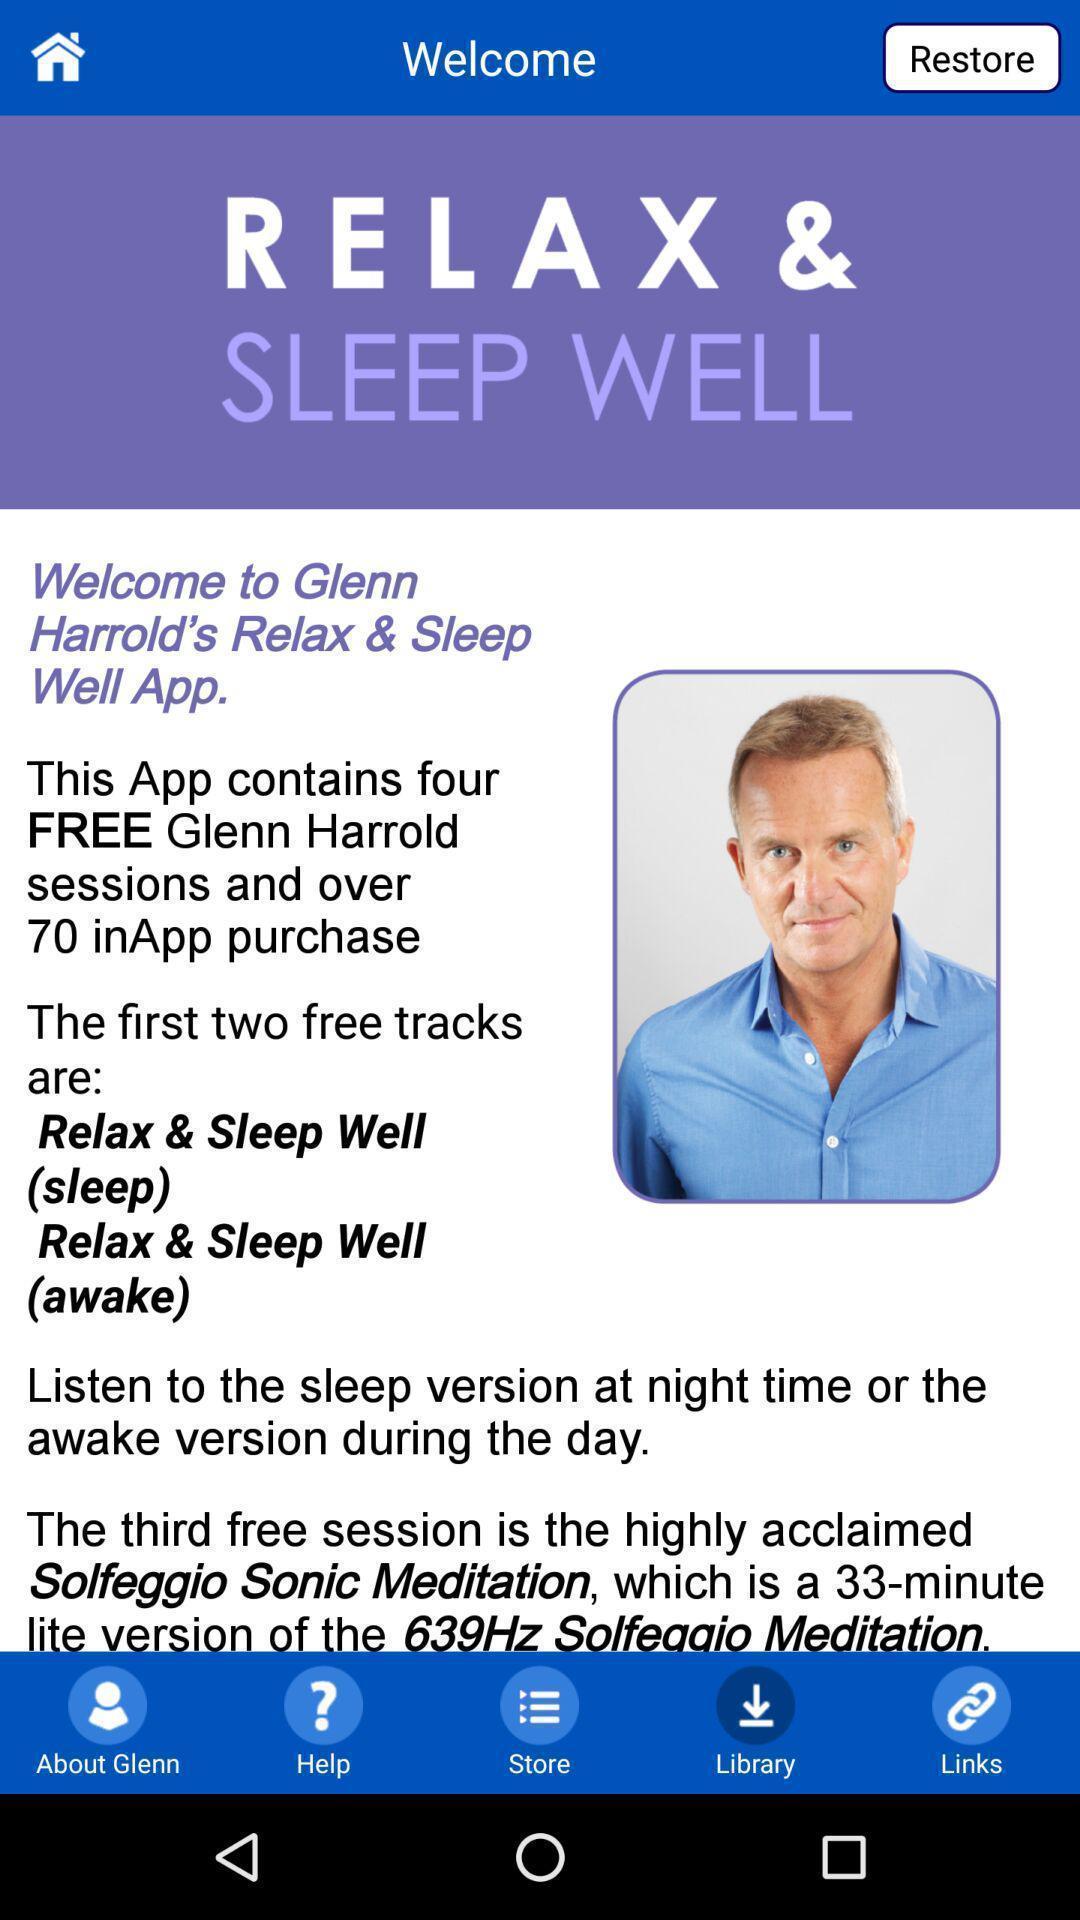Describe the content in this image. Welcome page of sleeping app. 